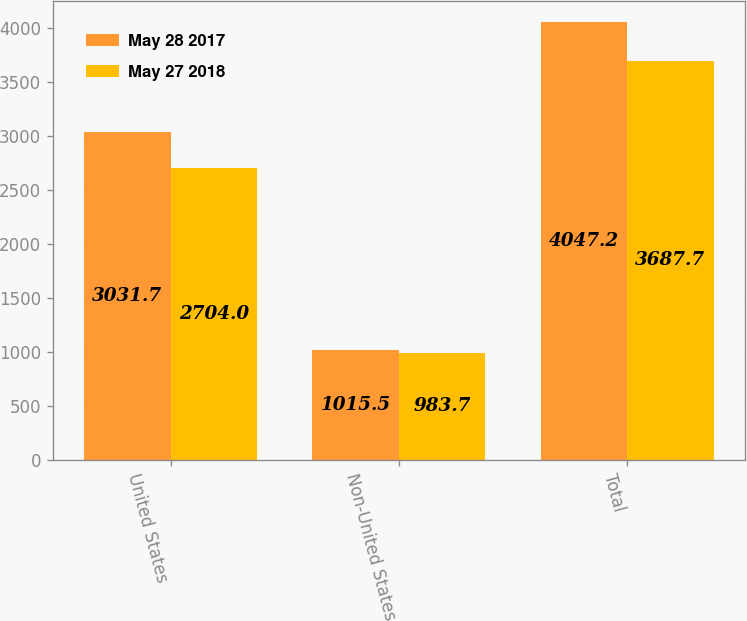Convert chart to OTSL. <chart><loc_0><loc_0><loc_500><loc_500><stacked_bar_chart><ecel><fcel>United States<fcel>Non-United States<fcel>Total<nl><fcel>May 28 2017<fcel>3031.7<fcel>1015.5<fcel>4047.2<nl><fcel>May 27 2018<fcel>2704<fcel>983.7<fcel>3687.7<nl></chart> 